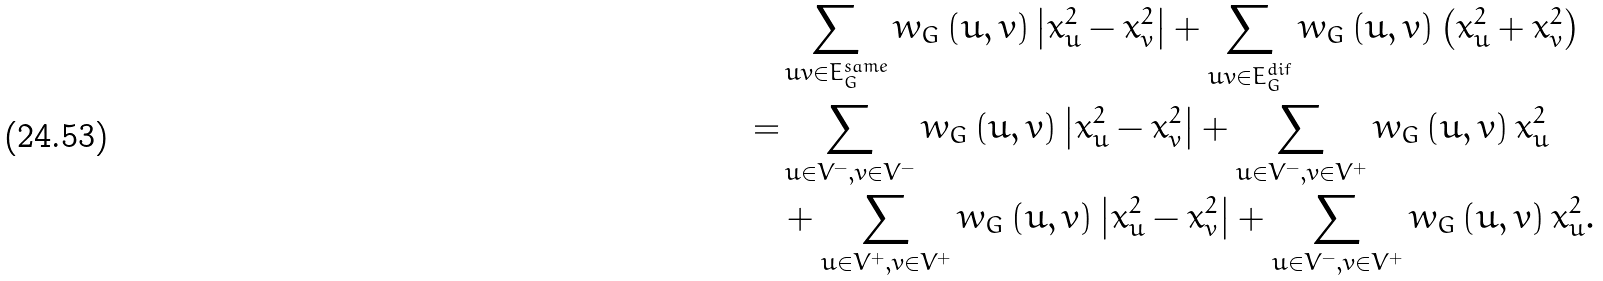<formula> <loc_0><loc_0><loc_500><loc_500>& \sum _ { u v \in E _ { G } ^ { s a m e } } w _ { G } \left ( u , v \right ) \left | x _ { u } ^ { 2 } - x _ { v } ^ { 2 } \right | + \sum _ { u v \in E _ { G } ^ { d i f } } w _ { G } \left ( u , v \right ) \left ( x _ { u } ^ { 2 } + x _ { v } ^ { 2 } \right ) \\ = & \sum _ { u \in V ^ { - } , v \in V ^ { - } } w _ { G } \left ( u , v \right ) \left | x _ { u } ^ { 2 } - x _ { v } ^ { 2 } \right | + \sum _ { u \in V ^ { - } , v \in V ^ { + } } w _ { G } \left ( u , v \right ) x _ { u } ^ { 2 } \\ & + \sum _ { u \in V ^ { + } , v \in V ^ { + } } w _ { G } \left ( u , v \right ) \left | x _ { u } ^ { 2 } - x _ { v } ^ { 2 } \right | + \sum _ { u \in V ^ { - } , v \in V ^ { + } } w _ { G } \left ( u , v \right ) x _ { u } ^ { 2 } .</formula> 